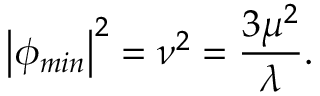Convert formula to latex. <formula><loc_0><loc_0><loc_500><loc_500>\left | \phi _ { \min } \right | ^ { 2 } = \nu ^ { 2 } = \frac { 3 \mu ^ { 2 } } { \lambda } .</formula> 